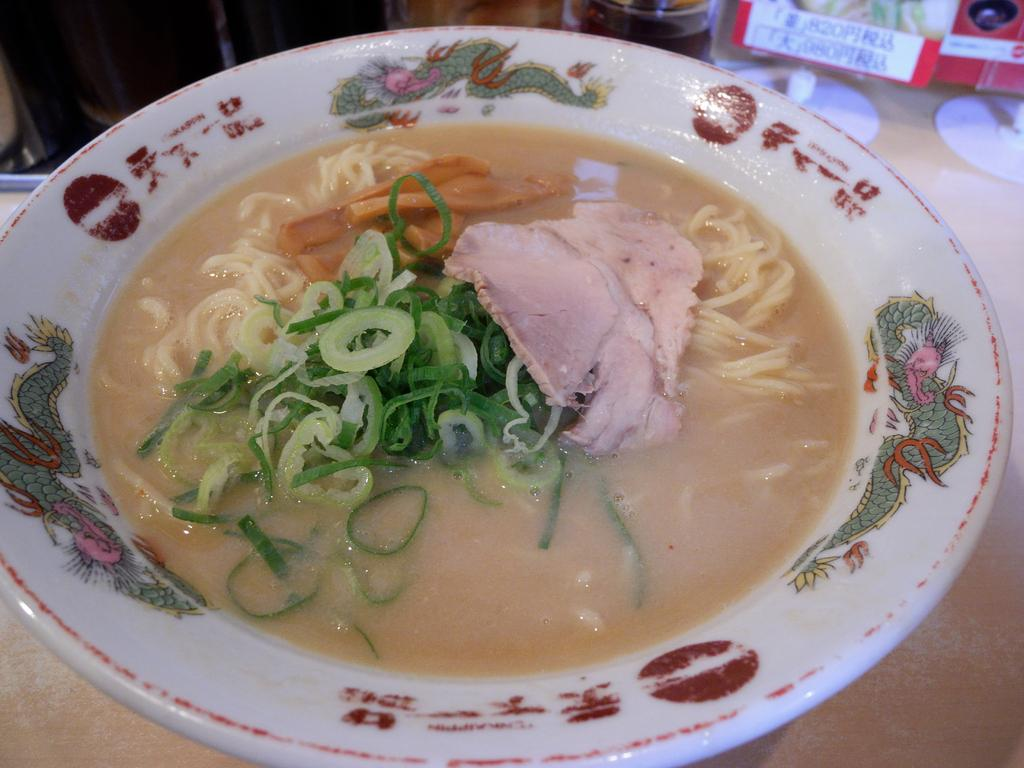What type of food can be seen in the image? There is an edible item in the image, which is soup. How is the soup presented in the image? The soup is placed in a plate. Is there any other edible item in the image besides the soup? Yes, there is an edible item in the image, which is also placed in the plate. What type of ink is used to write the recipe for the soup on the plate? There is no ink or recipe present on the plate in the image. The plate contains only the soup and another edible item. 